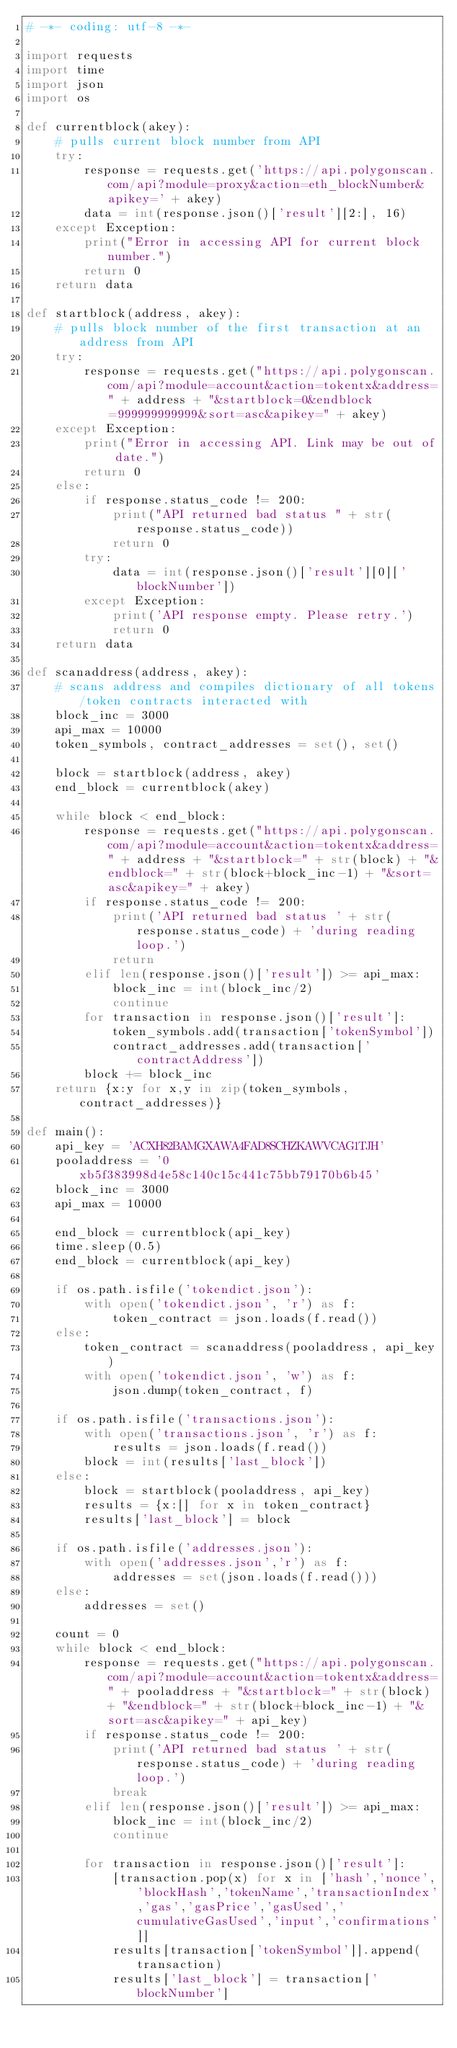<code> <loc_0><loc_0><loc_500><loc_500><_Python_># -*- coding: utf-8 -*-

import requests
import time
import json
import os

def currentblock(akey):
    # pulls current block number from API
    try:
        response = requests.get('https://api.polygonscan.com/api?module=proxy&action=eth_blockNumber&apikey=' + akey)
        data = int(response.json()['result'][2:], 16)
    except Exception:
        print("Error in accessing API for current block number.")
        return 0
    return data
     
def startblock(address, akey):
    # pulls block number of the first transaction at an address from API
    try:
        response = requests.get("https://api.polygonscan.com/api?module=account&action=tokentx&address=" + address + "&startblock=0&endblock=999999999999&sort=asc&apikey=" + akey)
    except Exception:
        print("Error in accessing API. Link may be out of date.")
        return 0
    else:
        if response.status_code != 200:
            print("API returned bad status " + str(response.status_code))
            return 0
        try:
            data = int(response.json()['result'][0]['blockNumber'])
        except Exception:
            print('API response empty. Please retry.')
            return 0
    return data
        
def scanaddress(address, akey):
    # scans address and compiles dictionary of all tokens/token contracts interacted with
    block_inc = 3000
    api_max = 10000
    token_symbols, contract_addresses = set(), set()
    
    block = startblock(address, akey)   
    end_block = currentblock(akey)    
    
    while block < end_block:
        response = requests.get("https://api.polygonscan.com/api?module=account&action=tokentx&address=" + address + "&startblock=" + str(block) + "&endblock=" + str(block+block_inc-1) + "&sort=asc&apikey=" + akey)
        if response.status_code != 200:
            print('API returned bad status ' + str(response.status_code) + 'during reading loop.')
            return
        elif len(response.json()['result']) >= api_max:
            block_inc = int(block_inc/2)
            continue
        for transaction in response.json()['result']:
            token_symbols.add(transaction['tokenSymbol'])
            contract_addresses.add(transaction['contractAddress'])
        block += block_inc
    return {x:y for x,y in zip(token_symbols, contract_addresses)}
      
def main():
    api_key = 'ACXH82BAMGXAWA4FAD8SCHZKAWVCAG1TJH'
    pooladdress = '0xb5f383998d4e58c140c15c441c75bb79170b6b45'
    block_inc = 3000
    api_max = 10000
    
    end_block = currentblock(api_key)
    time.sleep(0.5) 
    end_block = currentblock(api_key)
    
    if os.path.isfile('tokendict.json'):
        with open('tokendict.json', 'r') as f:
            token_contract = json.loads(f.read())
    else:
        token_contract = scanaddress(pooladdress, api_key)
        with open('tokendict.json', 'w') as f:
            json.dump(token_contract, f)
    
    if os.path.isfile('transactions.json'):
        with open('transactions.json', 'r') as f:
            results = json.loads(f.read())
        block = int(results['last_block'])
    else:
        block = startblock(pooladdress, api_key)
        results = {x:[] for x in token_contract}
        results['last_block'] = block
    
    if os.path.isfile('addresses.json'):
        with open('addresses.json','r') as f:
            addresses = set(json.loads(f.read()))
    else:
        addresses = set()
        
    count = 0    
    while block < end_block:
        response = requests.get("https://api.polygonscan.com/api?module=account&action=tokentx&address=" + pooladdress + "&startblock=" + str(block) + "&endblock=" + str(block+block_inc-1) + "&sort=asc&apikey=" + api_key)
        if response.status_code != 200:
            print('API returned bad status ' + str(response.status_code) + 'during reading loop.')
            break
        elif len(response.json()['result']) >= api_max:
            block_inc = int(block_inc/2)
            continue
        
        for transaction in response.json()['result']:
            [transaction.pop(x) for x in ['hash','nonce','blockHash','tokenName','transactionIndex','gas','gasPrice','gasUsed','cumulativeGasUsed','input','confirmations']]
            results[transaction['tokenSymbol']].append(transaction)
            results['last_block'] = transaction['blockNumber']</code> 